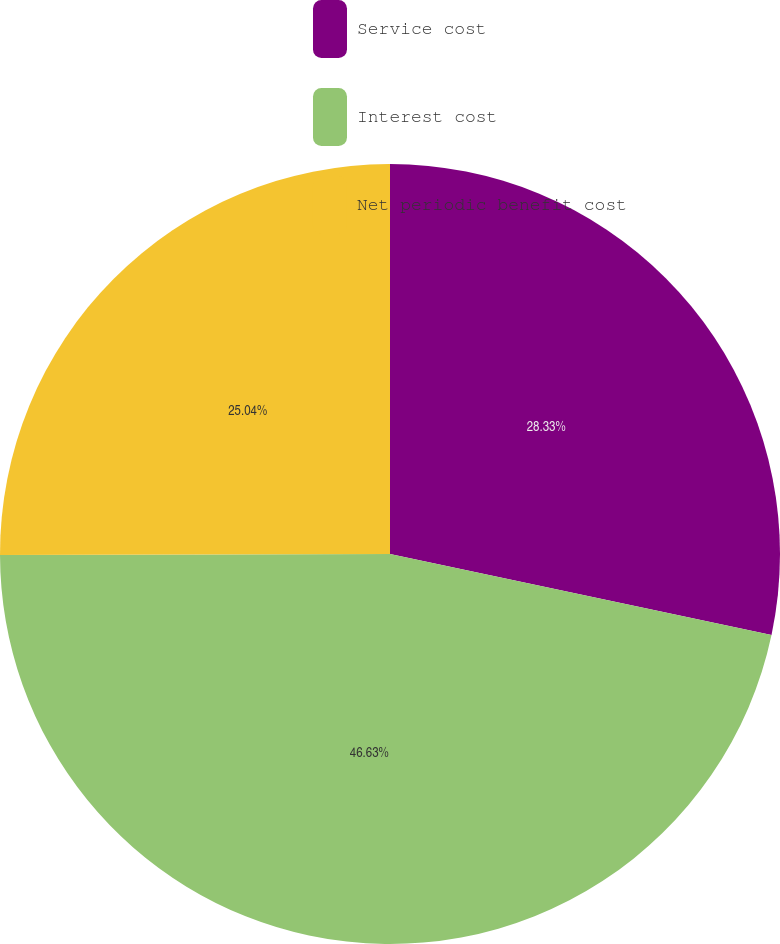Convert chart to OTSL. <chart><loc_0><loc_0><loc_500><loc_500><pie_chart><fcel>Service cost<fcel>Interest cost<fcel>Net periodic benefit cost<nl><fcel>28.33%<fcel>46.63%<fcel>25.04%<nl></chart> 